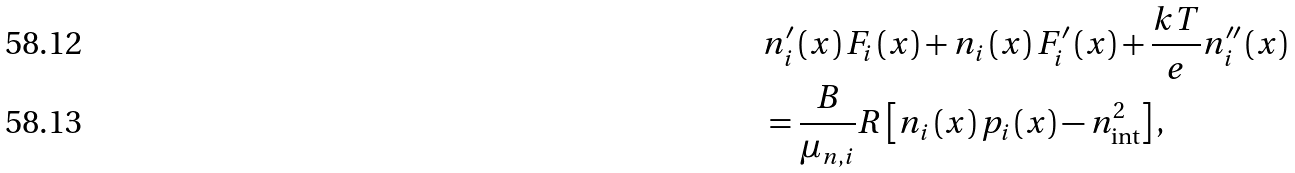Convert formula to latex. <formula><loc_0><loc_0><loc_500><loc_500>& n _ { i } ^ { \prime } \left ( x \right ) F _ { i } \left ( x \right ) + n _ { i } \left ( x \right ) F _ { i } ^ { \prime } \left ( x \right ) + \frac { k T } { e } n _ { i } ^ { \prime \prime } \left ( x \right ) \\ & = \frac { B } { \mu _ { n , i } } R \left [ n _ { i } \left ( x \right ) p _ { i } \left ( x \right ) - n _ { \text {int} } ^ { 2 } \right ] ,</formula> 